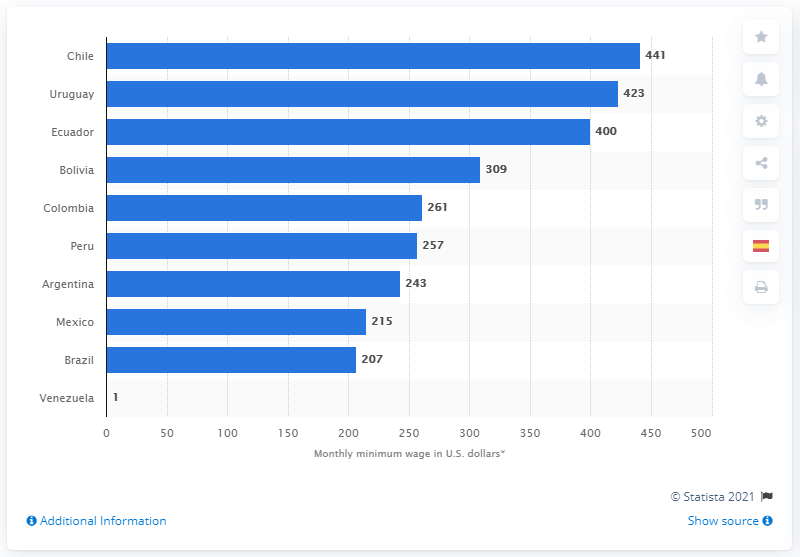List a handful of essential elements in this visual. Venezuela has the lowest minimum wage among the countries in Latin America. Chile has the highest minimum monthly wage among the countries in Latin America. 